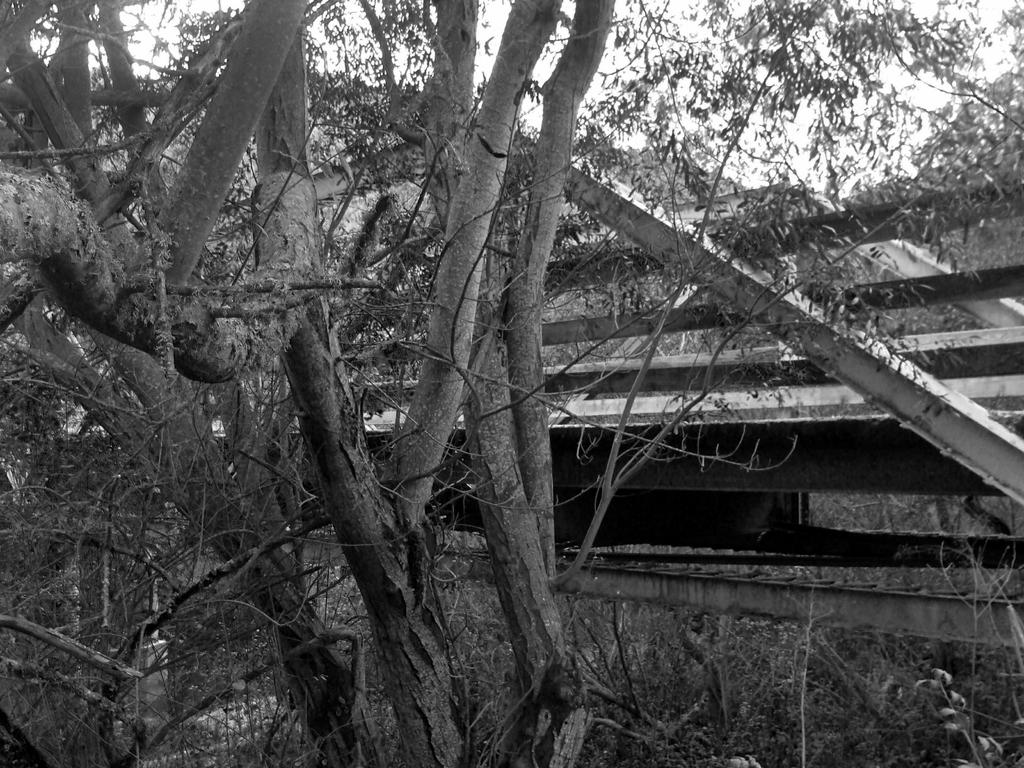What is the color scheme of the image? The image is black and white. What type of plant material can be seen in the image? There are dried branches and leaves in the image. What are the rods in the image used for? The purpose of the rods in the image is not specified, but they could be used for support or decoration. What type of smell can be detected from the image? There is no smell associated with the image, as it is a visual representation and not a physical object. 